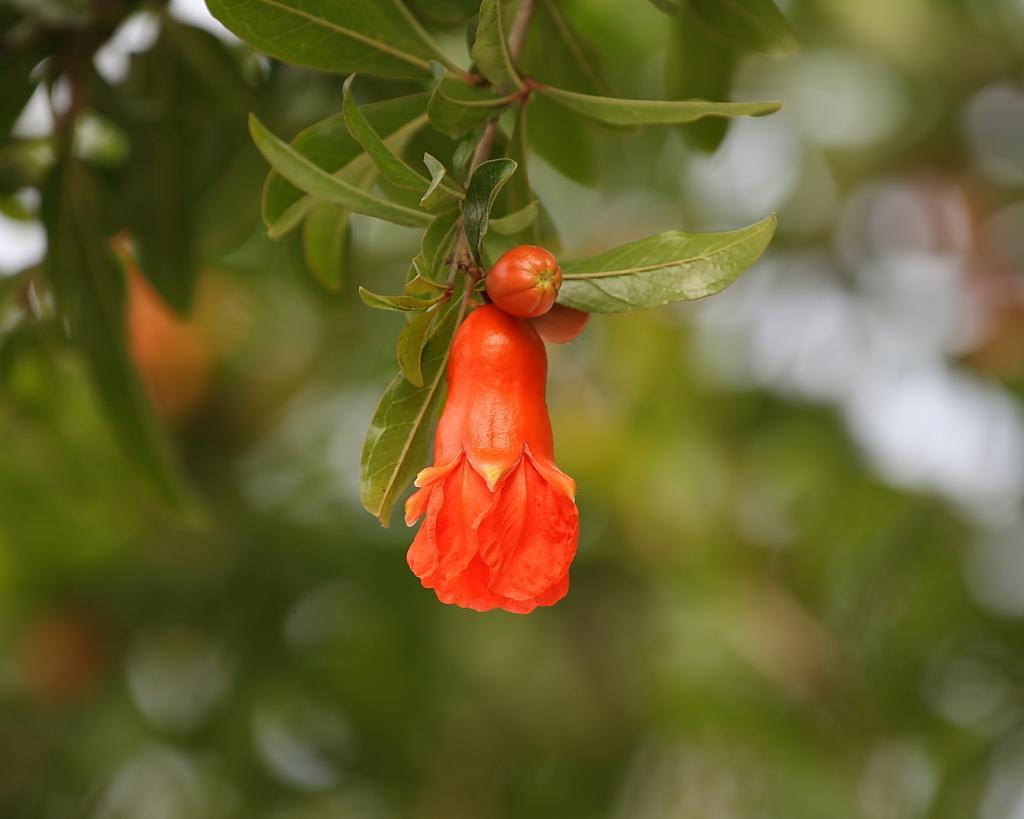Describe this image in one or two sentences. In the picture I can see the branch of a flowering plant. I can see a flower, bud of a flower and green leaves. 